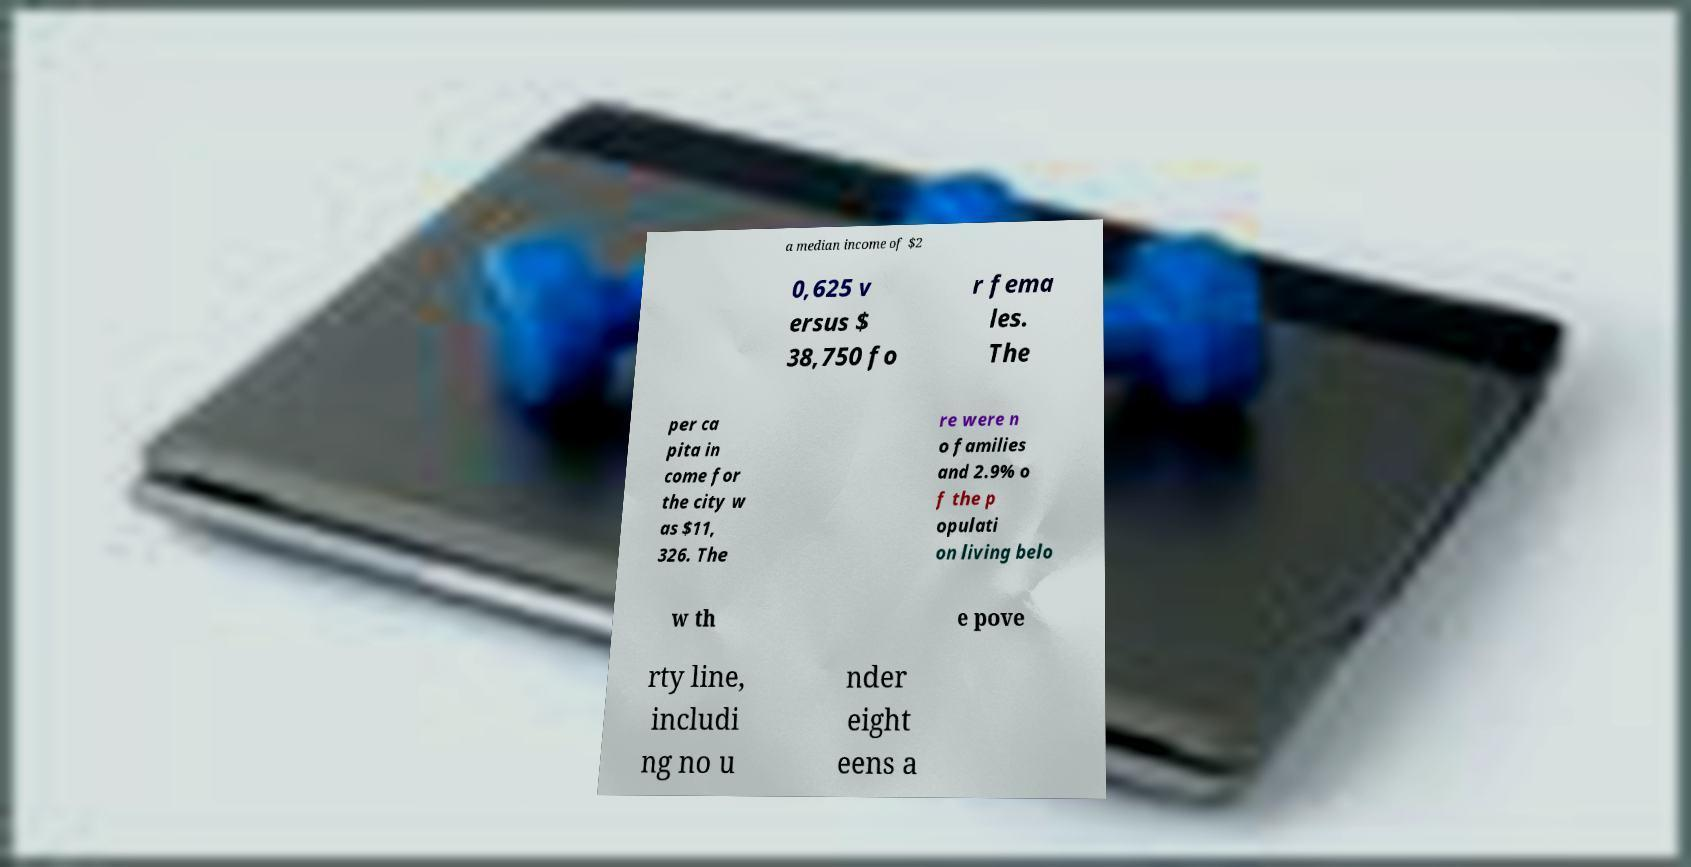There's text embedded in this image that I need extracted. Can you transcribe it verbatim? a median income of $2 0,625 v ersus $ 38,750 fo r fema les. The per ca pita in come for the city w as $11, 326. The re were n o families and 2.9% o f the p opulati on living belo w th e pove rty line, includi ng no u nder eight eens a 